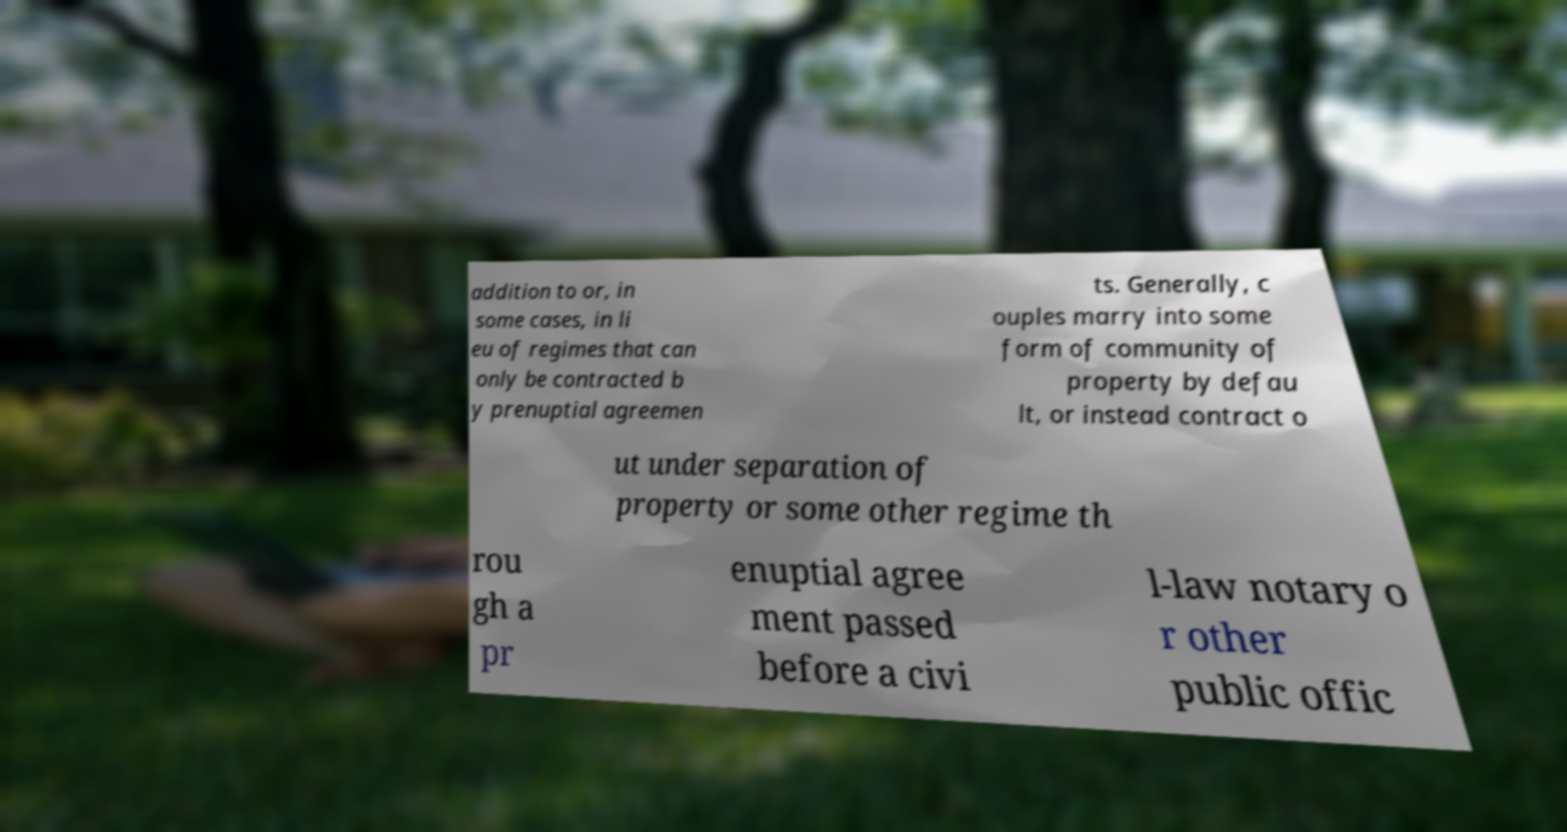What messages or text are displayed in this image? I need them in a readable, typed format. addition to or, in some cases, in li eu of regimes that can only be contracted b y prenuptial agreemen ts. Generally, c ouples marry into some form of community of property by defau lt, or instead contract o ut under separation of property or some other regime th rou gh a pr enuptial agree ment passed before a civi l-law notary o r other public offic 